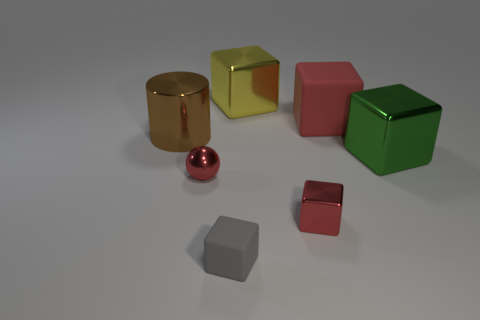Are there any small gray objects to the right of the red cube in front of the big cylinder left of the small gray rubber object?
Your answer should be compact. No. Does the yellow metal object that is behind the green shiny block have the same shape as the gray matte object?
Your answer should be compact. Yes. Are there fewer big brown things right of the large yellow metallic cube than big yellow metal objects in front of the big brown cylinder?
Offer a terse response. No. What material is the big yellow object?
Keep it short and to the point. Metal. There is a tiny ball; does it have the same color as the large shiny cube that is in front of the yellow cube?
Provide a succinct answer. No. What number of big yellow things are in front of the cylinder?
Offer a terse response. 0. Are there fewer big green metallic cubes in front of the green cube than big red rubber blocks?
Your answer should be very brief. Yes. What color is the large matte object?
Provide a succinct answer. Red. There is a tiny shiny thing on the right side of the small gray cube; is it the same color as the metallic cylinder?
Offer a terse response. No. What is the color of the big matte object that is the same shape as the large green shiny object?
Keep it short and to the point. Red. 